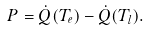Convert formula to latex. <formula><loc_0><loc_0><loc_500><loc_500>P = \dot { Q } ( T _ { e } ) - \dot { Q } ( T _ { l } ) .</formula> 